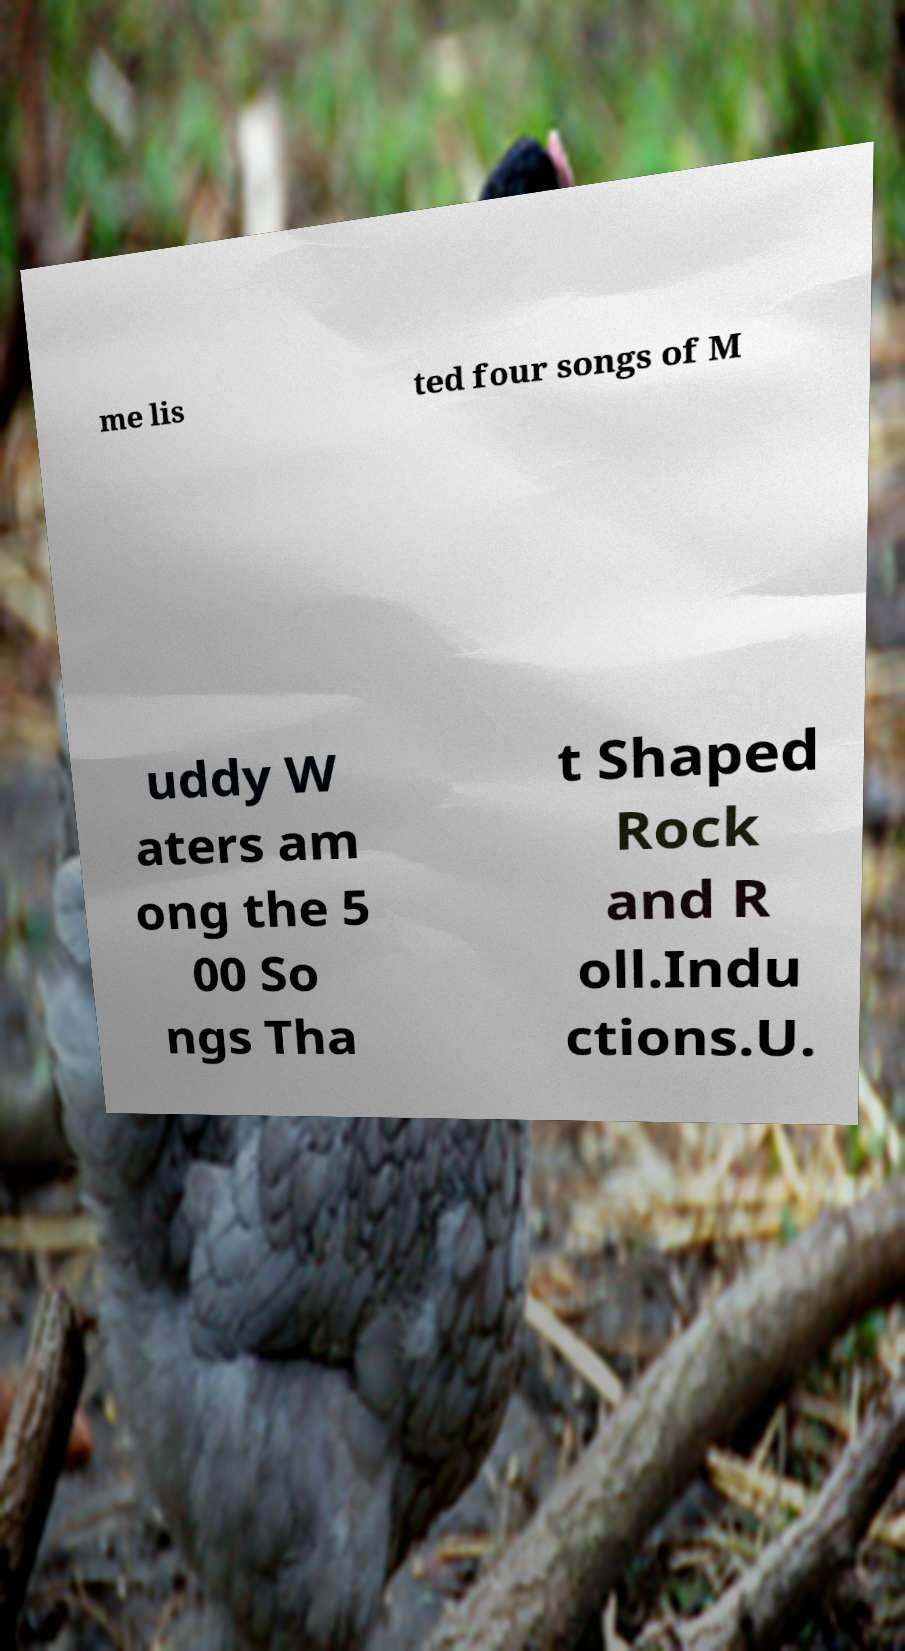I need the written content from this picture converted into text. Can you do that? me lis ted four songs of M uddy W aters am ong the 5 00 So ngs Tha t Shaped Rock and R oll.Indu ctions.U. 